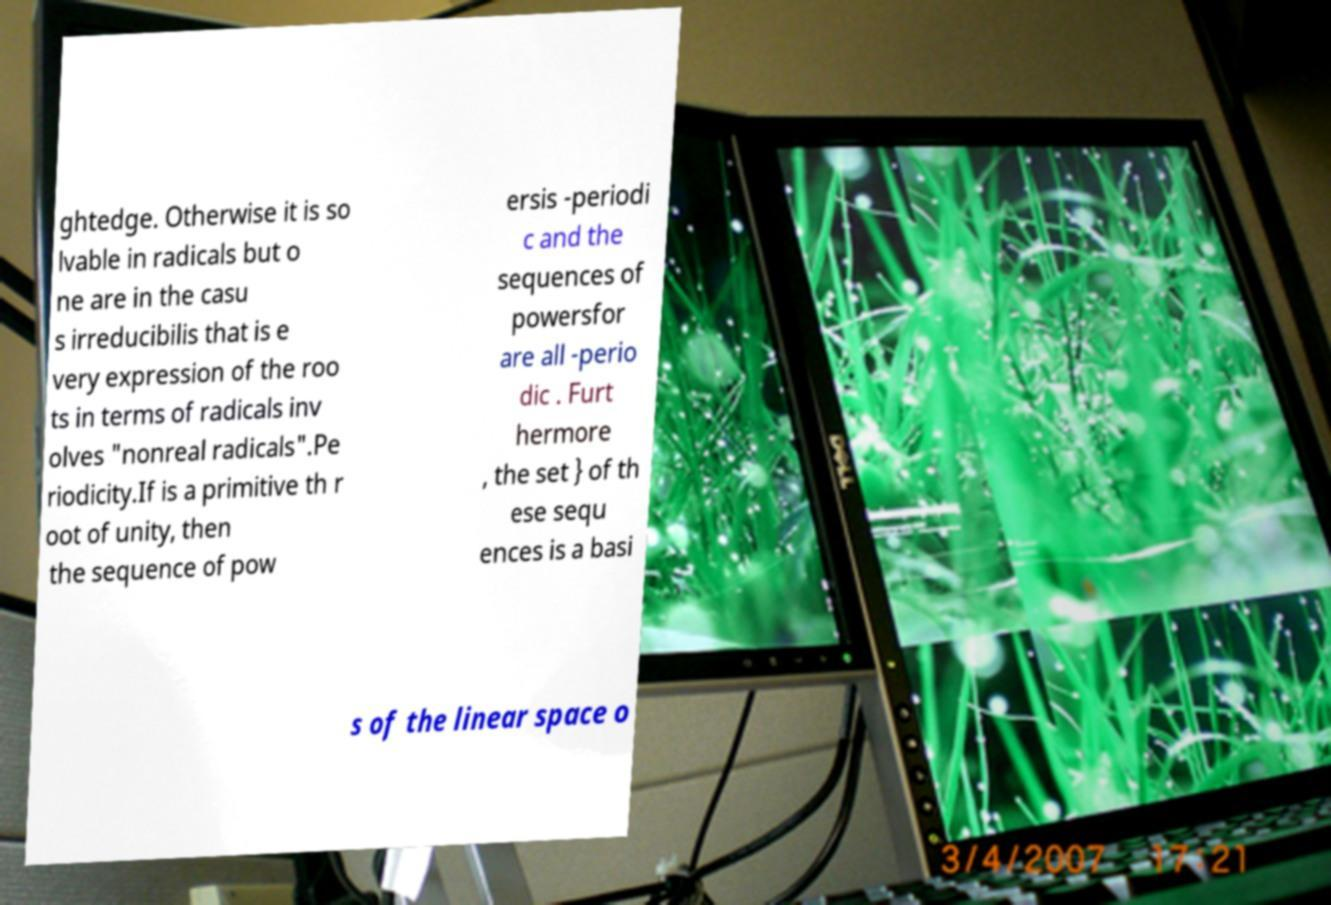For documentation purposes, I need the text within this image transcribed. Could you provide that? ghtedge. Otherwise it is so lvable in radicals but o ne are in the casu s irreducibilis that is e very expression of the roo ts in terms of radicals inv olves "nonreal radicals".Pe riodicity.If is a primitive th r oot of unity, then the sequence of pow ersis -periodi c and the sequences of powersfor are all -perio dic . Furt hermore , the set } of th ese sequ ences is a basi s of the linear space o 